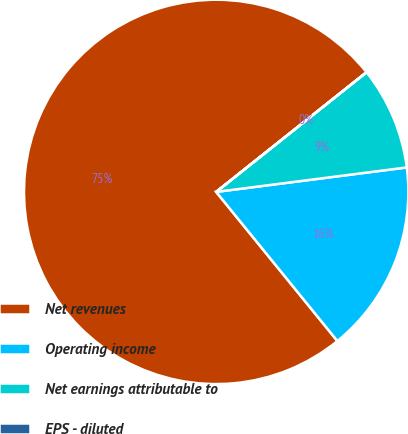<chart> <loc_0><loc_0><loc_500><loc_500><pie_chart><fcel>Net revenues<fcel>Operating income<fcel>Net earnings attributable to<fcel>EPS - diluted<nl><fcel>75.16%<fcel>16.17%<fcel>8.66%<fcel>0.01%<nl></chart> 